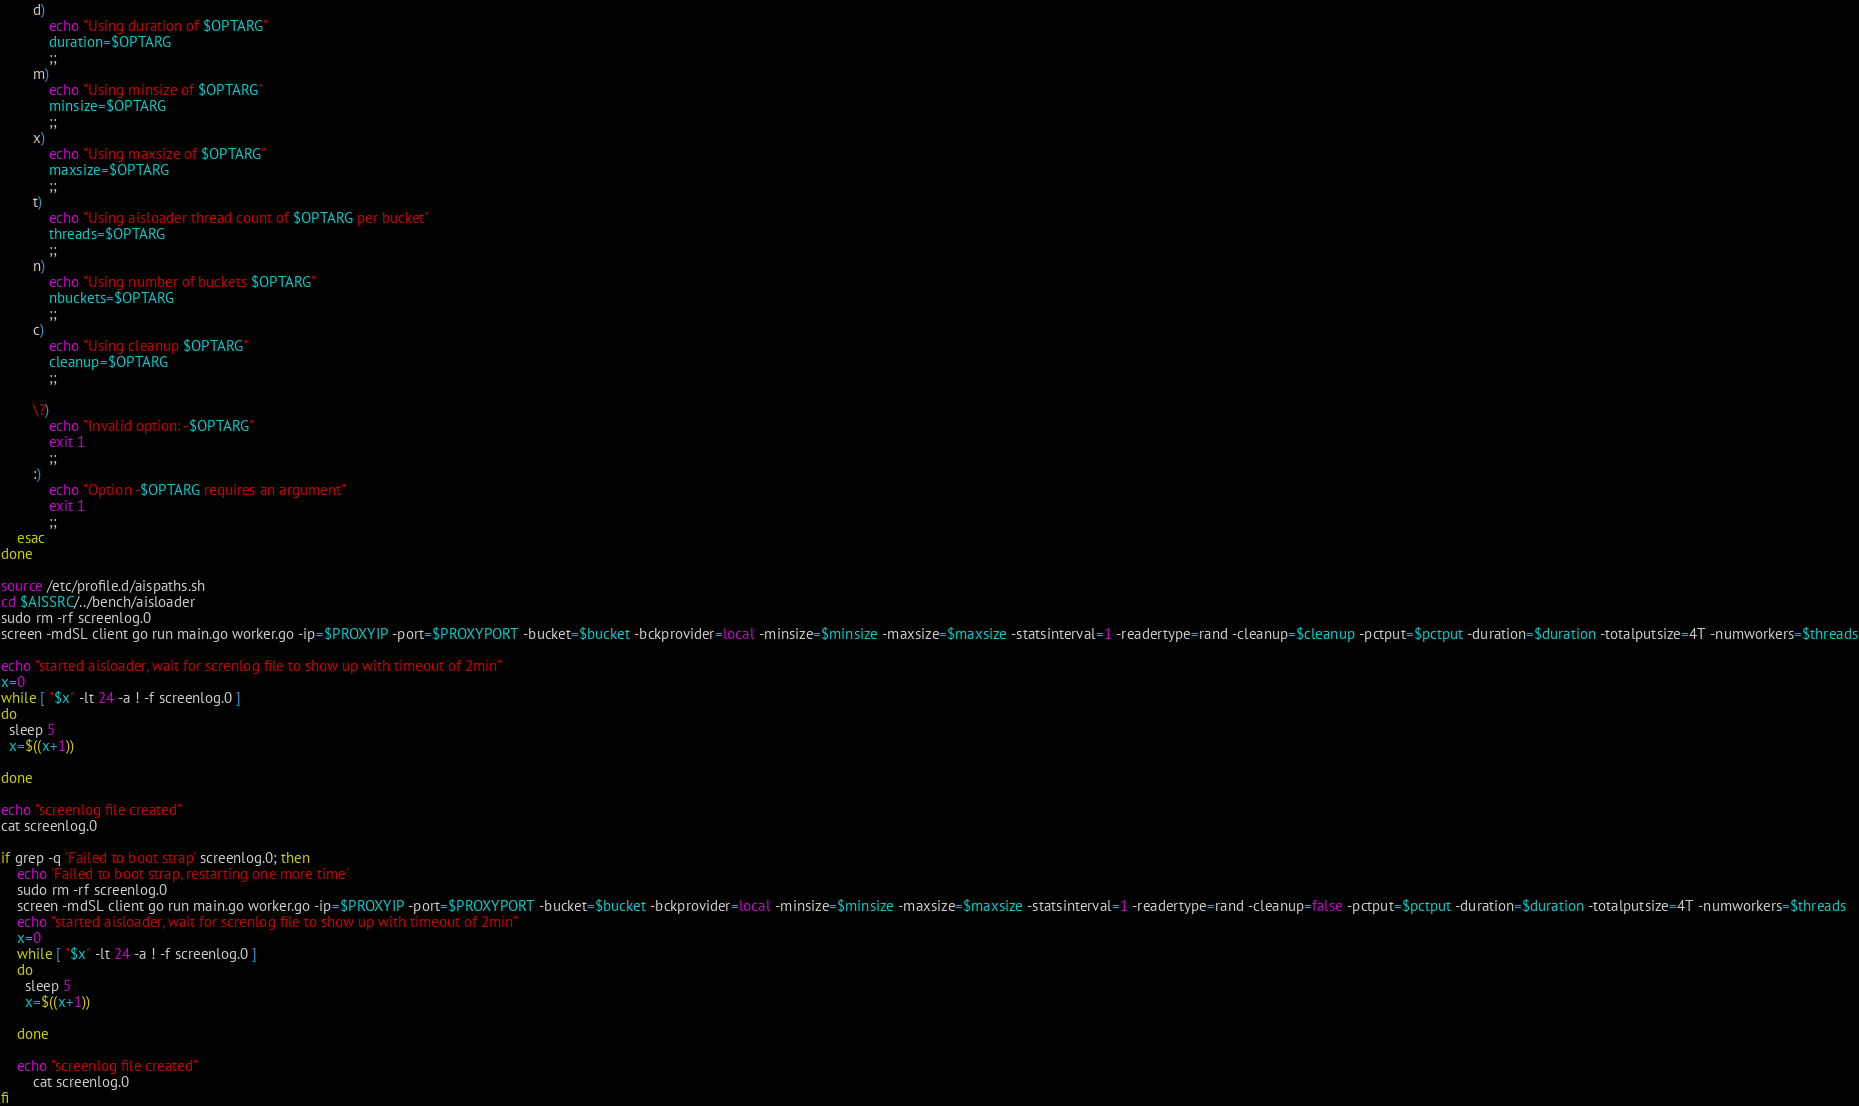Convert code to text. <code><loc_0><loc_0><loc_500><loc_500><_Bash_>        d)
            echo "Using duration of $OPTARG"
            duration=$OPTARG
            ;;
        m)
            echo "Using minsize of $OPTARG"
            minsize=$OPTARG
            ;;
        x)
            echo "Using maxsize of $OPTARG"
            maxsize=$OPTARG
            ;;
        t)
            echo "Using aisloader thread count of $OPTARG per bucket"
            threads=$OPTARG
            ;;
        n)
            echo "Using number of buckets $OPTARG"
            nbuckets=$OPTARG
            ;;
        c)
            echo "Using cleanup $OPTARG"
            cleanup=$OPTARG
            ;;

        \?)
            echo "Invalid option: -$OPTARG"
            exit 1
            ;;
        :)
            echo "Option -$OPTARG requires an argument"
            exit 1
            ;;
    esac
done

source /etc/profile.d/aispaths.sh
cd $AISSRC/../bench/aisloader
sudo rm -rf screenlog.0
screen -mdSL client go run main.go worker.go -ip=$PROXYIP -port=$PROXYPORT -bucket=$bucket -bckprovider=local -minsize=$minsize -maxsize=$maxsize -statsinterval=1 -readertype=rand -cleanup=$cleanup -pctput=$pctput -duration=$duration -totalputsize=4T -numworkers=$threads

echo "started aisloader, wait for screnlog file to show up with timeout of 2min"
x=0
while [ "$x" -lt 24 -a ! -f screenlog.0 ]
do
  sleep 5
  x=$((x+1))

done

echo "screenlog file created"
cat screenlog.0

if grep -q 'Failed to boot strap' screenlog.0; then
	echo 'Failed to boot strap, restarting one more time'
	sudo rm -rf screenlog.0
	screen -mdSL client go run main.go worker.go -ip=$PROXYIP -port=$PROXYPORT -bucket=$bucket -bckprovider=local -minsize=$minsize -maxsize=$maxsize -statsinterval=1 -readertype=rand -cleanup=false -pctput=$pctput -duration=$duration -totalputsize=4T -numworkers=$threads
	echo "started aisloader, wait for screnlog file to show up with timeout of 2min"
	x=0
	while [ "$x" -lt 24 -a ! -f screenlog.0 ]
	do
	  sleep 5
	  x=$((x+1))

	done

	echo "screenlog file created"
        cat screenlog.0
fi
</code> 